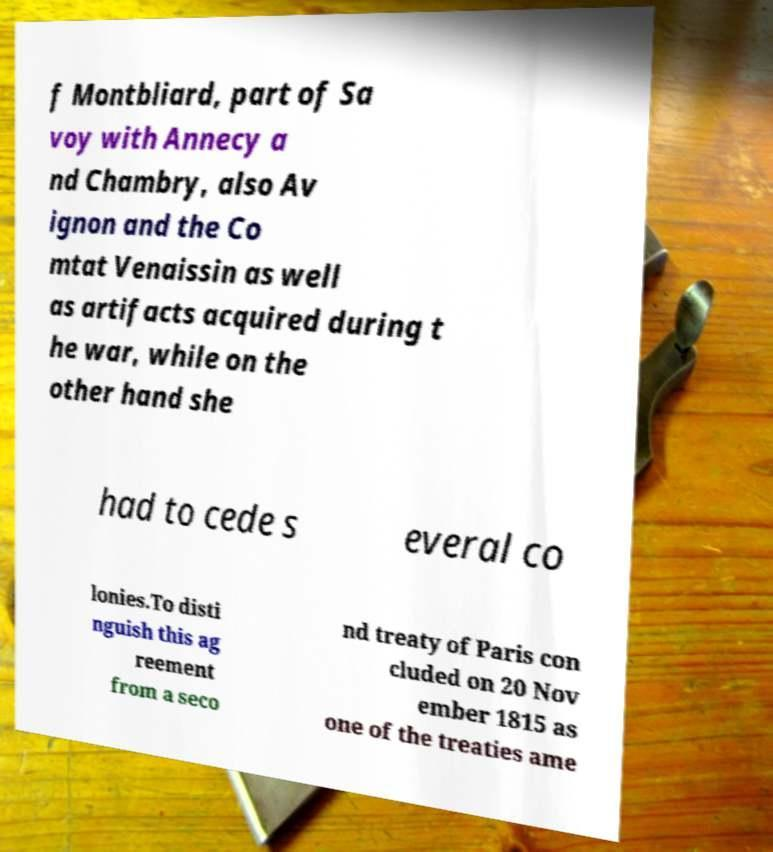Please read and relay the text visible in this image. What does it say? f Montbliard, part of Sa voy with Annecy a nd Chambry, also Av ignon and the Co mtat Venaissin as well as artifacts acquired during t he war, while on the other hand she had to cede s everal co lonies.To disti nguish this ag reement from a seco nd treaty of Paris con cluded on 20 Nov ember 1815 as one of the treaties ame 